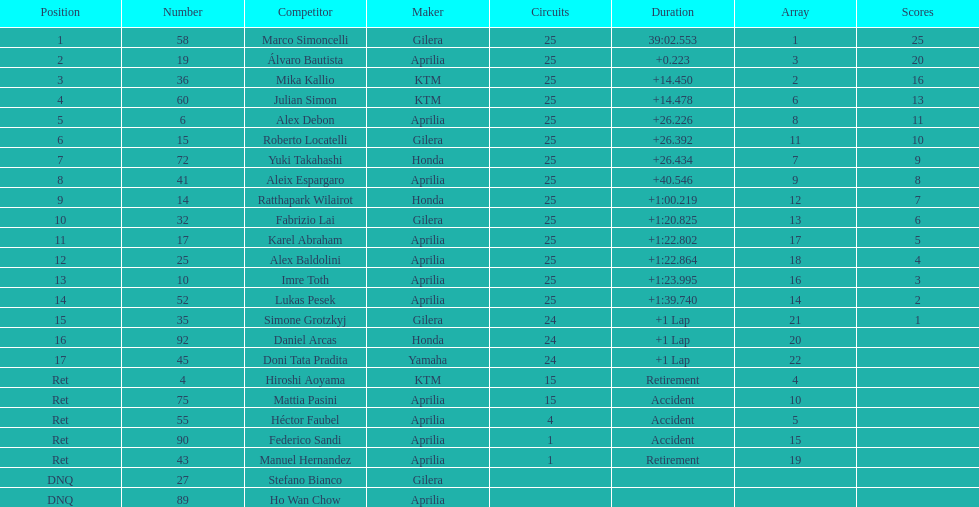Did marco simoncelli or alvaro bautista held rank 1? Marco Simoncelli. 